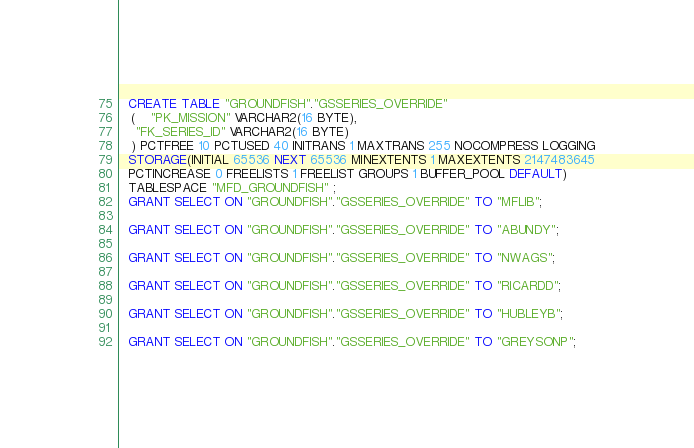Convert code to text. <code><loc_0><loc_0><loc_500><loc_500><_SQL_>  CREATE TABLE "GROUNDFISH"."GSSERIES_OVERRIDE" 
   (	"PK_MISSION" VARCHAR2(16 BYTE), 
	"FK_SERIES_ID" VARCHAR2(16 BYTE)
   ) PCTFREE 10 PCTUSED 40 INITRANS 1 MAXTRANS 255 NOCOMPRESS LOGGING
  STORAGE(INITIAL 65536 NEXT 65536 MINEXTENTS 1 MAXEXTENTS 2147483645
  PCTINCREASE 0 FREELISTS 1 FREELIST GROUPS 1 BUFFER_POOL DEFAULT)
  TABLESPACE "MFD_GROUNDFISH" ;
  GRANT SELECT ON "GROUNDFISH"."GSSERIES_OVERRIDE" TO "MFLIB";
 
  GRANT SELECT ON "GROUNDFISH"."GSSERIES_OVERRIDE" TO "ABUNDY";
 
  GRANT SELECT ON "GROUNDFISH"."GSSERIES_OVERRIDE" TO "NWAGS";
 
  GRANT SELECT ON "GROUNDFISH"."GSSERIES_OVERRIDE" TO "RICARDD";
 
  GRANT SELECT ON "GROUNDFISH"."GSSERIES_OVERRIDE" TO "HUBLEYB";
 
  GRANT SELECT ON "GROUNDFISH"."GSSERIES_OVERRIDE" TO "GREYSONP";
</code> 